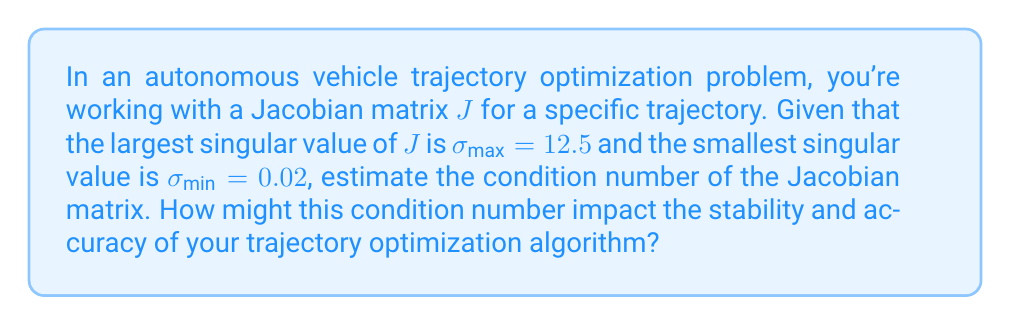Can you solve this math problem? Let's approach this step-by-step:

1) The condition number of a matrix is defined as the ratio of its largest to smallest singular values:

   $$\kappa(J) = \frac{\sigma_{\text{max}}}{\sigma_{\text{min}}}$$

2) We are given:
   $\sigma_{\text{max}} = 12.5$
   $\sigma_{\text{min}} = 0.02$

3) Substituting these values into the formula:

   $$\kappa(J) = \frac{12.5}{0.02} = 625$$

4) Impact on trajectory optimization:
   
   a) A high condition number (like 625) indicates that the Jacobian matrix is ill-conditioned.
   
   b) This means that small changes in the input (e.g., slight variations in sensor data or initial conditions) can lead to large changes in the output (the optimized trajectory).
   
   c) In the context of autonomous vehicles, this could result in:
      - Reduced stability of the optimization algorithm
      - Increased sensitivity to noise and measurement errors
      - Potential difficulties in converging to an optimal solution
      - Less reliable trajectory predictions, especially in complex driving scenarios

   d) To mitigate these issues, you might consider:
      - Regularization techniques to improve the conditioning of the problem
      - Using robust optimization methods that are less sensitive to ill-conditioning
      - Increasing the precision of computations or using specialized numerical methods for ill-conditioned problems
Answer: 625; High condition number indicates ill-conditioning, leading to potential instability and reduced accuracy in trajectory optimization. 